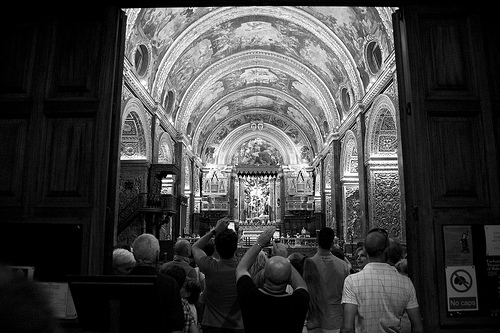Describe the overall atmosphere in the image. The overall atmosphere in the image conveys a sense of reverence and admiration. The visitors appear to be in awe of the grand and intricate design of the church's interior, accentuated by the dramatic lighting and artistic details. 